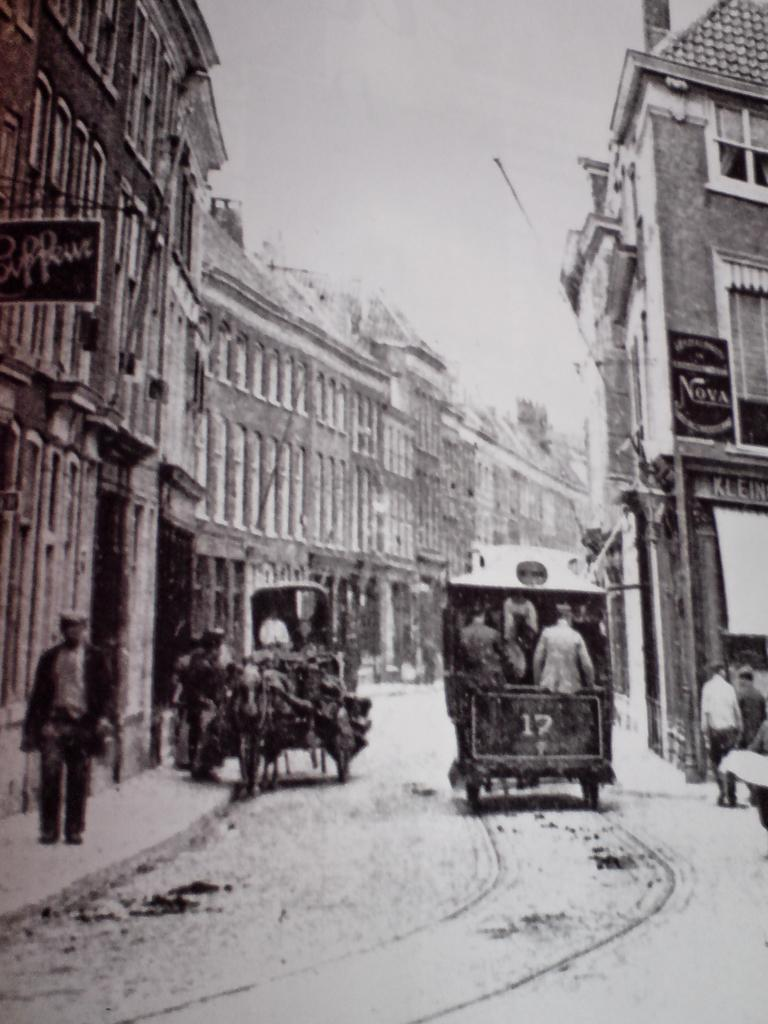What is the color scheme of the image? The image is black and white. Who or what can be seen in the image? There are people in the image. What objects are present in the image? There are carts and boards in the image. What type of man-made structure is visible in the image? There are buildings in the image. What is the natural element visible in the background of the image? The sky is visible in the background of the image. What is the primary mode of transportation depicted in the image? The carts suggest that the primary mode of transportation in the image is by cart. What type of dress is the person wearing in the image? The image is black and white, so it is not possible to determine the type of dress the person might be wearing. What emotion can be seen on the person's face in the image? The image is black and white, and there is no indication of the person's emotions or facial expressions. 